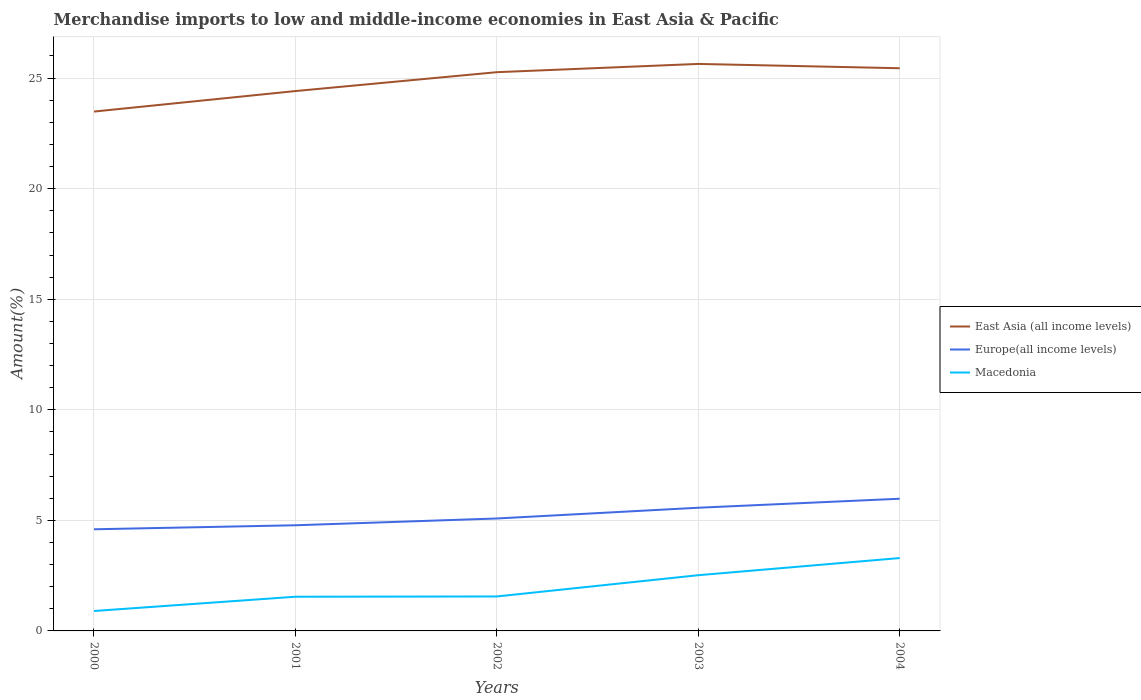Does the line corresponding to East Asia (all income levels) intersect with the line corresponding to Macedonia?
Your response must be concise. No. Is the number of lines equal to the number of legend labels?
Provide a short and direct response. Yes. Across all years, what is the maximum percentage of amount earned from merchandise imports in East Asia (all income levels)?
Keep it short and to the point. 23.49. What is the total percentage of amount earned from merchandise imports in Macedonia in the graph?
Give a very brief answer. -1.74. What is the difference between the highest and the second highest percentage of amount earned from merchandise imports in Europe(all income levels)?
Provide a short and direct response. 1.38. What is the difference between the highest and the lowest percentage of amount earned from merchandise imports in Macedonia?
Keep it short and to the point. 2. How many lines are there?
Offer a very short reply. 3. What is the difference between two consecutive major ticks on the Y-axis?
Your answer should be very brief. 5. How many legend labels are there?
Give a very brief answer. 3. What is the title of the graph?
Keep it short and to the point. Merchandise imports to low and middle-income economies in East Asia & Pacific. What is the label or title of the X-axis?
Keep it short and to the point. Years. What is the label or title of the Y-axis?
Your answer should be very brief. Amount(%). What is the Amount(%) in East Asia (all income levels) in 2000?
Offer a very short reply. 23.49. What is the Amount(%) in Europe(all income levels) in 2000?
Your answer should be very brief. 4.6. What is the Amount(%) of Macedonia in 2000?
Your answer should be compact. 0.9. What is the Amount(%) in East Asia (all income levels) in 2001?
Offer a terse response. 24.41. What is the Amount(%) of Europe(all income levels) in 2001?
Ensure brevity in your answer.  4.78. What is the Amount(%) in Macedonia in 2001?
Offer a very short reply. 1.55. What is the Amount(%) of East Asia (all income levels) in 2002?
Provide a short and direct response. 25.27. What is the Amount(%) in Europe(all income levels) in 2002?
Ensure brevity in your answer.  5.08. What is the Amount(%) of Macedonia in 2002?
Make the answer very short. 1.56. What is the Amount(%) in East Asia (all income levels) in 2003?
Your answer should be compact. 25.64. What is the Amount(%) of Europe(all income levels) in 2003?
Make the answer very short. 5.57. What is the Amount(%) in Macedonia in 2003?
Make the answer very short. 2.52. What is the Amount(%) of East Asia (all income levels) in 2004?
Give a very brief answer. 25.45. What is the Amount(%) of Europe(all income levels) in 2004?
Provide a succinct answer. 5.98. What is the Amount(%) in Macedonia in 2004?
Offer a very short reply. 3.3. Across all years, what is the maximum Amount(%) of East Asia (all income levels)?
Offer a terse response. 25.64. Across all years, what is the maximum Amount(%) of Europe(all income levels)?
Ensure brevity in your answer.  5.98. Across all years, what is the maximum Amount(%) in Macedonia?
Offer a very short reply. 3.3. Across all years, what is the minimum Amount(%) of East Asia (all income levels)?
Give a very brief answer. 23.49. Across all years, what is the minimum Amount(%) of Europe(all income levels)?
Give a very brief answer. 4.6. Across all years, what is the minimum Amount(%) of Macedonia?
Give a very brief answer. 0.9. What is the total Amount(%) in East Asia (all income levels) in the graph?
Provide a succinct answer. 124.26. What is the total Amount(%) in Europe(all income levels) in the graph?
Offer a very short reply. 26.01. What is the total Amount(%) of Macedonia in the graph?
Make the answer very short. 9.82. What is the difference between the Amount(%) in East Asia (all income levels) in 2000 and that in 2001?
Offer a very short reply. -0.93. What is the difference between the Amount(%) of Europe(all income levels) in 2000 and that in 2001?
Offer a very short reply. -0.18. What is the difference between the Amount(%) of Macedonia in 2000 and that in 2001?
Ensure brevity in your answer.  -0.65. What is the difference between the Amount(%) of East Asia (all income levels) in 2000 and that in 2002?
Give a very brief answer. -1.78. What is the difference between the Amount(%) of Europe(all income levels) in 2000 and that in 2002?
Provide a succinct answer. -0.49. What is the difference between the Amount(%) in Macedonia in 2000 and that in 2002?
Keep it short and to the point. -0.66. What is the difference between the Amount(%) in East Asia (all income levels) in 2000 and that in 2003?
Make the answer very short. -2.15. What is the difference between the Amount(%) in Europe(all income levels) in 2000 and that in 2003?
Offer a terse response. -0.97. What is the difference between the Amount(%) in Macedonia in 2000 and that in 2003?
Give a very brief answer. -1.62. What is the difference between the Amount(%) in East Asia (all income levels) in 2000 and that in 2004?
Offer a terse response. -1.96. What is the difference between the Amount(%) in Europe(all income levels) in 2000 and that in 2004?
Ensure brevity in your answer.  -1.38. What is the difference between the Amount(%) of Macedonia in 2000 and that in 2004?
Keep it short and to the point. -2.4. What is the difference between the Amount(%) of East Asia (all income levels) in 2001 and that in 2002?
Your response must be concise. -0.85. What is the difference between the Amount(%) of Europe(all income levels) in 2001 and that in 2002?
Make the answer very short. -0.31. What is the difference between the Amount(%) in Macedonia in 2001 and that in 2002?
Keep it short and to the point. -0.01. What is the difference between the Amount(%) of East Asia (all income levels) in 2001 and that in 2003?
Your response must be concise. -1.23. What is the difference between the Amount(%) of Europe(all income levels) in 2001 and that in 2003?
Your answer should be very brief. -0.79. What is the difference between the Amount(%) of Macedonia in 2001 and that in 2003?
Keep it short and to the point. -0.97. What is the difference between the Amount(%) in East Asia (all income levels) in 2001 and that in 2004?
Give a very brief answer. -1.03. What is the difference between the Amount(%) of Europe(all income levels) in 2001 and that in 2004?
Give a very brief answer. -1.2. What is the difference between the Amount(%) of Macedonia in 2001 and that in 2004?
Provide a succinct answer. -1.75. What is the difference between the Amount(%) in East Asia (all income levels) in 2002 and that in 2003?
Your answer should be very brief. -0.37. What is the difference between the Amount(%) in Europe(all income levels) in 2002 and that in 2003?
Ensure brevity in your answer.  -0.49. What is the difference between the Amount(%) of Macedonia in 2002 and that in 2003?
Offer a very short reply. -0.96. What is the difference between the Amount(%) of East Asia (all income levels) in 2002 and that in 2004?
Offer a terse response. -0.18. What is the difference between the Amount(%) in Europe(all income levels) in 2002 and that in 2004?
Your response must be concise. -0.89. What is the difference between the Amount(%) of Macedonia in 2002 and that in 2004?
Your answer should be very brief. -1.74. What is the difference between the Amount(%) of East Asia (all income levels) in 2003 and that in 2004?
Offer a terse response. 0.2. What is the difference between the Amount(%) in Europe(all income levels) in 2003 and that in 2004?
Your answer should be very brief. -0.41. What is the difference between the Amount(%) in Macedonia in 2003 and that in 2004?
Give a very brief answer. -0.78. What is the difference between the Amount(%) in East Asia (all income levels) in 2000 and the Amount(%) in Europe(all income levels) in 2001?
Your answer should be very brief. 18.71. What is the difference between the Amount(%) in East Asia (all income levels) in 2000 and the Amount(%) in Macedonia in 2001?
Keep it short and to the point. 21.94. What is the difference between the Amount(%) in Europe(all income levels) in 2000 and the Amount(%) in Macedonia in 2001?
Your response must be concise. 3.05. What is the difference between the Amount(%) of East Asia (all income levels) in 2000 and the Amount(%) of Europe(all income levels) in 2002?
Provide a succinct answer. 18.4. What is the difference between the Amount(%) of East Asia (all income levels) in 2000 and the Amount(%) of Macedonia in 2002?
Offer a terse response. 21.93. What is the difference between the Amount(%) of Europe(all income levels) in 2000 and the Amount(%) of Macedonia in 2002?
Ensure brevity in your answer.  3.04. What is the difference between the Amount(%) in East Asia (all income levels) in 2000 and the Amount(%) in Europe(all income levels) in 2003?
Your answer should be very brief. 17.92. What is the difference between the Amount(%) of East Asia (all income levels) in 2000 and the Amount(%) of Macedonia in 2003?
Ensure brevity in your answer.  20.97. What is the difference between the Amount(%) of Europe(all income levels) in 2000 and the Amount(%) of Macedonia in 2003?
Your answer should be compact. 2.08. What is the difference between the Amount(%) in East Asia (all income levels) in 2000 and the Amount(%) in Europe(all income levels) in 2004?
Ensure brevity in your answer.  17.51. What is the difference between the Amount(%) in East Asia (all income levels) in 2000 and the Amount(%) in Macedonia in 2004?
Make the answer very short. 20.19. What is the difference between the Amount(%) of Europe(all income levels) in 2000 and the Amount(%) of Macedonia in 2004?
Your response must be concise. 1.3. What is the difference between the Amount(%) of East Asia (all income levels) in 2001 and the Amount(%) of Europe(all income levels) in 2002?
Provide a succinct answer. 19.33. What is the difference between the Amount(%) in East Asia (all income levels) in 2001 and the Amount(%) in Macedonia in 2002?
Your response must be concise. 22.86. What is the difference between the Amount(%) in Europe(all income levels) in 2001 and the Amount(%) in Macedonia in 2002?
Make the answer very short. 3.22. What is the difference between the Amount(%) in East Asia (all income levels) in 2001 and the Amount(%) in Europe(all income levels) in 2003?
Your answer should be very brief. 18.84. What is the difference between the Amount(%) of East Asia (all income levels) in 2001 and the Amount(%) of Macedonia in 2003?
Ensure brevity in your answer.  21.89. What is the difference between the Amount(%) in Europe(all income levels) in 2001 and the Amount(%) in Macedonia in 2003?
Make the answer very short. 2.26. What is the difference between the Amount(%) of East Asia (all income levels) in 2001 and the Amount(%) of Europe(all income levels) in 2004?
Provide a succinct answer. 18.44. What is the difference between the Amount(%) in East Asia (all income levels) in 2001 and the Amount(%) in Macedonia in 2004?
Ensure brevity in your answer.  21.12. What is the difference between the Amount(%) of Europe(all income levels) in 2001 and the Amount(%) of Macedonia in 2004?
Ensure brevity in your answer.  1.48. What is the difference between the Amount(%) of East Asia (all income levels) in 2002 and the Amount(%) of Europe(all income levels) in 2003?
Ensure brevity in your answer.  19.7. What is the difference between the Amount(%) of East Asia (all income levels) in 2002 and the Amount(%) of Macedonia in 2003?
Ensure brevity in your answer.  22.75. What is the difference between the Amount(%) in Europe(all income levels) in 2002 and the Amount(%) in Macedonia in 2003?
Provide a succinct answer. 2.56. What is the difference between the Amount(%) in East Asia (all income levels) in 2002 and the Amount(%) in Europe(all income levels) in 2004?
Your answer should be compact. 19.29. What is the difference between the Amount(%) in East Asia (all income levels) in 2002 and the Amount(%) in Macedonia in 2004?
Give a very brief answer. 21.97. What is the difference between the Amount(%) in Europe(all income levels) in 2002 and the Amount(%) in Macedonia in 2004?
Your answer should be compact. 1.79. What is the difference between the Amount(%) in East Asia (all income levels) in 2003 and the Amount(%) in Europe(all income levels) in 2004?
Your response must be concise. 19.66. What is the difference between the Amount(%) in East Asia (all income levels) in 2003 and the Amount(%) in Macedonia in 2004?
Your answer should be very brief. 22.35. What is the difference between the Amount(%) of Europe(all income levels) in 2003 and the Amount(%) of Macedonia in 2004?
Offer a very short reply. 2.27. What is the average Amount(%) of East Asia (all income levels) per year?
Make the answer very short. 24.85. What is the average Amount(%) in Europe(all income levels) per year?
Offer a terse response. 5.2. What is the average Amount(%) of Macedonia per year?
Ensure brevity in your answer.  1.96. In the year 2000, what is the difference between the Amount(%) of East Asia (all income levels) and Amount(%) of Europe(all income levels)?
Your answer should be compact. 18.89. In the year 2000, what is the difference between the Amount(%) of East Asia (all income levels) and Amount(%) of Macedonia?
Give a very brief answer. 22.59. In the year 2000, what is the difference between the Amount(%) in Europe(all income levels) and Amount(%) in Macedonia?
Your answer should be very brief. 3.7. In the year 2001, what is the difference between the Amount(%) of East Asia (all income levels) and Amount(%) of Europe(all income levels)?
Provide a short and direct response. 19.64. In the year 2001, what is the difference between the Amount(%) in East Asia (all income levels) and Amount(%) in Macedonia?
Offer a very short reply. 22.87. In the year 2001, what is the difference between the Amount(%) of Europe(all income levels) and Amount(%) of Macedonia?
Provide a succinct answer. 3.23. In the year 2002, what is the difference between the Amount(%) in East Asia (all income levels) and Amount(%) in Europe(all income levels)?
Provide a succinct answer. 20.18. In the year 2002, what is the difference between the Amount(%) in East Asia (all income levels) and Amount(%) in Macedonia?
Offer a terse response. 23.71. In the year 2002, what is the difference between the Amount(%) of Europe(all income levels) and Amount(%) of Macedonia?
Your answer should be very brief. 3.53. In the year 2003, what is the difference between the Amount(%) of East Asia (all income levels) and Amount(%) of Europe(all income levels)?
Your answer should be compact. 20.07. In the year 2003, what is the difference between the Amount(%) in East Asia (all income levels) and Amount(%) in Macedonia?
Your answer should be compact. 23.12. In the year 2003, what is the difference between the Amount(%) of Europe(all income levels) and Amount(%) of Macedonia?
Ensure brevity in your answer.  3.05. In the year 2004, what is the difference between the Amount(%) of East Asia (all income levels) and Amount(%) of Europe(all income levels)?
Ensure brevity in your answer.  19.47. In the year 2004, what is the difference between the Amount(%) in East Asia (all income levels) and Amount(%) in Macedonia?
Your answer should be very brief. 22.15. In the year 2004, what is the difference between the Amount(%) in Europe(all income levels) and Amount(%) in Macedonia?
Provide a short and direct response. 2.68. What is the ratio of the Amount(%) of East Asia (all income levels) in 2000 to that in 2001?
Offer a very short reply. 0.96. What is the ratio of the Amount(%) of Macedonia in 2000 to that in 2001?
Offer a very short reply. 0.58. What is the ratio of the Amount(%) in East Asia (all income levels) in 2000 to that in 2002?
Ensure brevity in your answer.  0.93. What is the ratio of the Amount(%) of Europe(all income levels) in 2000 to that in 2002?
Offer a terse response. 0.9. What is the ratio of the Amount(%) of Macedonia in 2000 to that in 2002?
Ensure brevity in your answer.  0.58. What is the ratio of the Amount(%) in East Asia (all income levels) in 2000 to that in 2003?
Give a very brief answer. 0.92. What is the ratio of the Amount(%) in Europe(all income levels) in 2000 to that in 2003?
Your answer should be compact. 0.83. What is the ratio of the Amount(%) in Macedonia in 2000 to that in 2003?
Provide a short and direct response. 0.36. What is the ratio of the Amount(%) of East Asia (all income levels) in 2000 to that in 2004?
Offer a very short reply. 0.92. What is the ratio of the Amount(%) of Europe(all income levels) in 2000 to that in 2004?
Keep it short and to the point. 0.77. What is the ratio of the Amount(%) in Macedonia in 2000 to that in 2004?
Provide a short and direct response. 0.27. What is the ratio of the Amount(%) of East Asia (all income levels) in 2001 to that in 2002?
Offer a very short reply. 0.97. What is the ratio of the Amount(%) in Europe(all income levels) in 2001 to that in 2002?
Offer a very short reply. 0.94. What is the ratio of the Amount(%) in Macedonia in 2001 to that in 2002?
Offer a terse response. 0.99. What is the ratio of the Amount(%) of East Asia (all income levels) in 2001 to that in 2003?
Provide a short and direct response. 0.95. What is the ratio of the Amount(%) of Europe(all income levels) in 2001 to that in 2003?
Your response must be concise. 0.86. What is the ratio of the Amount(%) in Macedonia in 2001 to that in 2003?
Make the answer very short. 0.61. What is the ratio of the Amount(%) in East Asia (all income levels) in 2001 to that in 2004?
Offer a very short reply. 0.96. What is the ratio of the Amount(%) in Europe(all income levels) in 2001 to that in 2004?
Ensure brevity in your answer.  0.8. What is the ratio of the Amount(%) in Macedonia in 2001 to that in 2004?
Keep it short and to the point. 0.47. What is the ratio of the Amount(%) of East Asia (all income levels) in 2002 to that in 2003?
Your response must be concise. 0.99. What is the ratio of the Amount(%) of Europe(all income levels) in 2002 to that in 2003?
Keep it short and to the point. 0.91. What is the ratio of the Amount(%) in Macedonia in 2002 to that in 2003?
Ensure brevity in your answer.  0.62. What is the ratio of the Amount(%) of East Asia (all income levels) in 2002 to that in 2004?
Offer a very short reply. 0.99. What is the ratio of the Amount(%) of Europe(all income levels) in 2002 to that in 2004?
Offer a very short reply. 0.85. What is the ratio of the Amount(%) in Macedonia in 2002 to that in 2004?
Your response must be concise. 0.47. What is the ratio of the Amount(%) in East Asia (all income levels) in 2003 to that in 2004?
Make the answer very short. 1.01. What is the ratio of the Amount(%) in Europe(all income levels) in 2003 to that in 2004?
Your answer should be compact. 0.93. What is the ratio of the Amount(%) in Macedonia in 2003 to that in 2004?
Your answer should be very brief. 0.76. What is the difference between the highest and the second highest Amount(%) in East Asia (all income levels)?
Your answer should be compact. 0.2. What is the difference between the highest and the second highest Amount(%) in Europe(all income levels)?
Keep it short and to the point. 0.41. What is the difference between the highest and the second highest Amount(%) of Macedonia?
Provide a short and direct response. 0.78. What is the difference between the highest and the lowest Amount(%) in East Asia (all income levels)?
Make the answer very short. 2.15. What is the difference between the highest and the lowest Amount(%) of Europe(all income levels)?
Keep it short and to the point. 1.38. What is the difference between the highest and the lowest Amount(%) of Macedonia?
Your response must be concise. 2.4. 